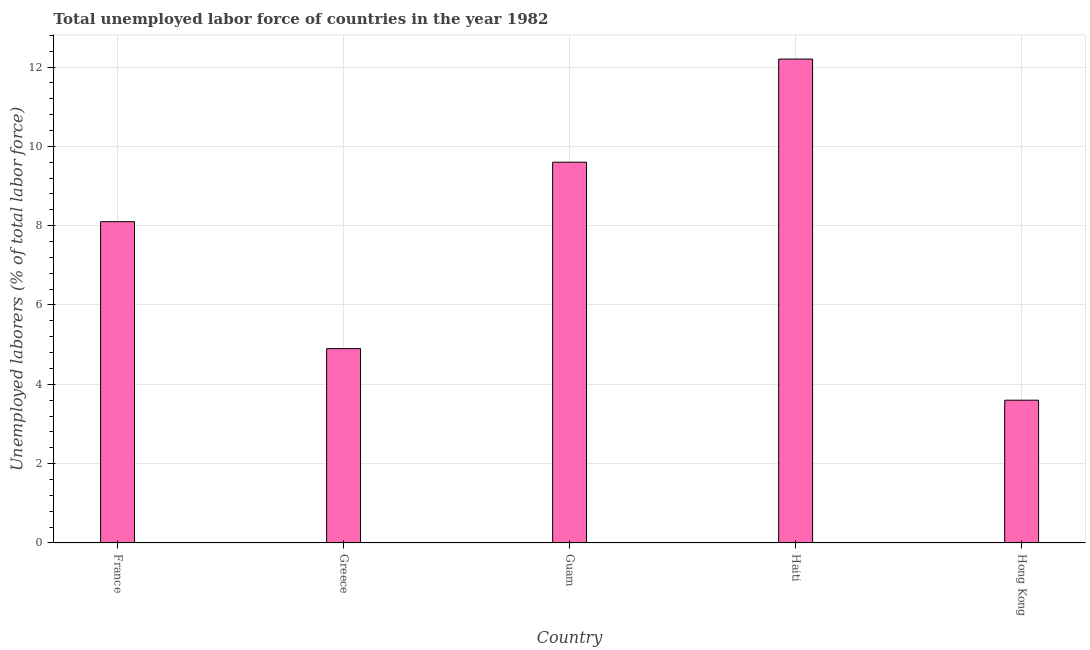What is the title of the graph?
Keep it short and to the point. Total unemployed labor force of countries in the year 1982. What is the label or title of the X-axis?
Provide a short and direct response. Country. What is the label or title of the Y-axis?
Your answer should be very brief. Unemployed laborers (% of total labor force). What is the total unemployed labour force in Hong Kong?
Your response must be concise. 3.6. Across all countries, what is the maximum total unemployed labour force?
Provide a short and direct response. 12.2. Across all countries, what is the minimum total unemployed labour force?
Ensure brevity in your answer.  3.6. In which country was the total unemployed labour force maximum?
Your response must be concise. Haiti. In which country was the total unemployed labour force minimum?
Your answer should be compact. Hong Kong. What is the sum of the total unemployed labour force?
Make the answer very short. 38.4. What is the average total unemployed labour force per country?
Your answer should be compact. 7.68. What is the median total unemployed labour force?
Offer a terse response. 8.1. What is the ratio of the total unemployed labour force in France to that in Greece?
Your response must be concise. 1.65. Is the total unemployed labour force in Greece less than that in Hong Kong?
Your response must be concise. No. Is the difference between the total unemployed labour force in France and Guam greater than the difference between any two countries?
Your response must be concise. No. What is the difference between the highest and the lowest total unemployed labour force?
Offer a very short reply. 8.6. In how many countries, is the total unemployed labour force greater than the average total unemployed labour force taken over all countries?
Provide a succinct answer. 3. How many bars are there?
Provide a succinct answer. 5. Are all the bars in the graph horizontal?
Offer a terse response. No. How many countries are there in the graph?
Make the answer very short. 5. What is the difference between two consecutive major ticks on the Y-axis?
Offer a terse response. 2. What is the Unemployed laborers (% of total labor force) of France?
Provide a short and direct response. 8.1. What is the Unemployed laborers (% of total labor force) in Greece?
Your response must be concise. 4.9. What is the Unemployed laborers (% of total labor force) in Guam?
Your response must be concise. 9.6. What is the Unemployed laborers (% of total labor force) of Haiti?
Provide a succinct answer. 12.2. What is the Unemployed laborers (% of total labor force) of Hong Kong?
Your answer should be very brief. 3.6. What is the difference between the Unemployed laborers (% of total labor force) in France and Guam?
Make the answer very short. -1.5. What is the difference between the Unemployed laborers (% of total labor force) in France and Haiti?
Keep it short and to the point. -4.1. What is the difference between the Unemployed laborers (% of total labor force) in France and Hong Kong?
Offer a terse response. 4.5. What is the difference between the Unemployed laborers (% of total labor force) in Guam and Haiti?
Ensure brevity in your answer.  -2.6. What is the difference between the Unemployed laborers (% of total labor force) in Guam and Hong Kong?
Your answer should be compact. 6. What is the ratio of the Unemployed laborers (% of total labor force) in France to that in Greece?
Your answer should be compact. 1.65. What is the ratio of the Unemployed laborers (% of total labor force) in France to that in Guam?
Ensure brevity in your answer.  0.84. What is the ratio of the Unemployed laborers (% of total labor force) in France to that in Haiti?
Provide a succinct answer. 0.66. What is the ratio of the Unemployed laborers (% of total labor force) in France to that in Hong Kong?
Ensure brevity in your answer.  2.25. What is the ratio of the Unemployed laborers (% of total labor force) in Greece to that in Guam?
Give a very brief answer. 0.51. What is the ratio of the Unemployed laborers (% of total labor force) in Greece to that in Haiti?
Your response must be concise. 0.4. What is the ratio of the Unemployed laborers (% of total labor force) in Greece to that in Hong Kong?
Provide a short and direct response. 1.36. What is the ratio of the Unemployed laborers (% of total labor force) in Guam to that in Haiti?
Offer a terse response. 0.79. What is the ratio of the Unemployed laborers (% of total labor force) in Guam to that in Hong Kong?
Your answer should be compact. 2.67. What is the ratio of the Unemployed laborers (% of total labor force) in Haiti to that in Hong Kong?
Your answer should be compact. 3.39. 